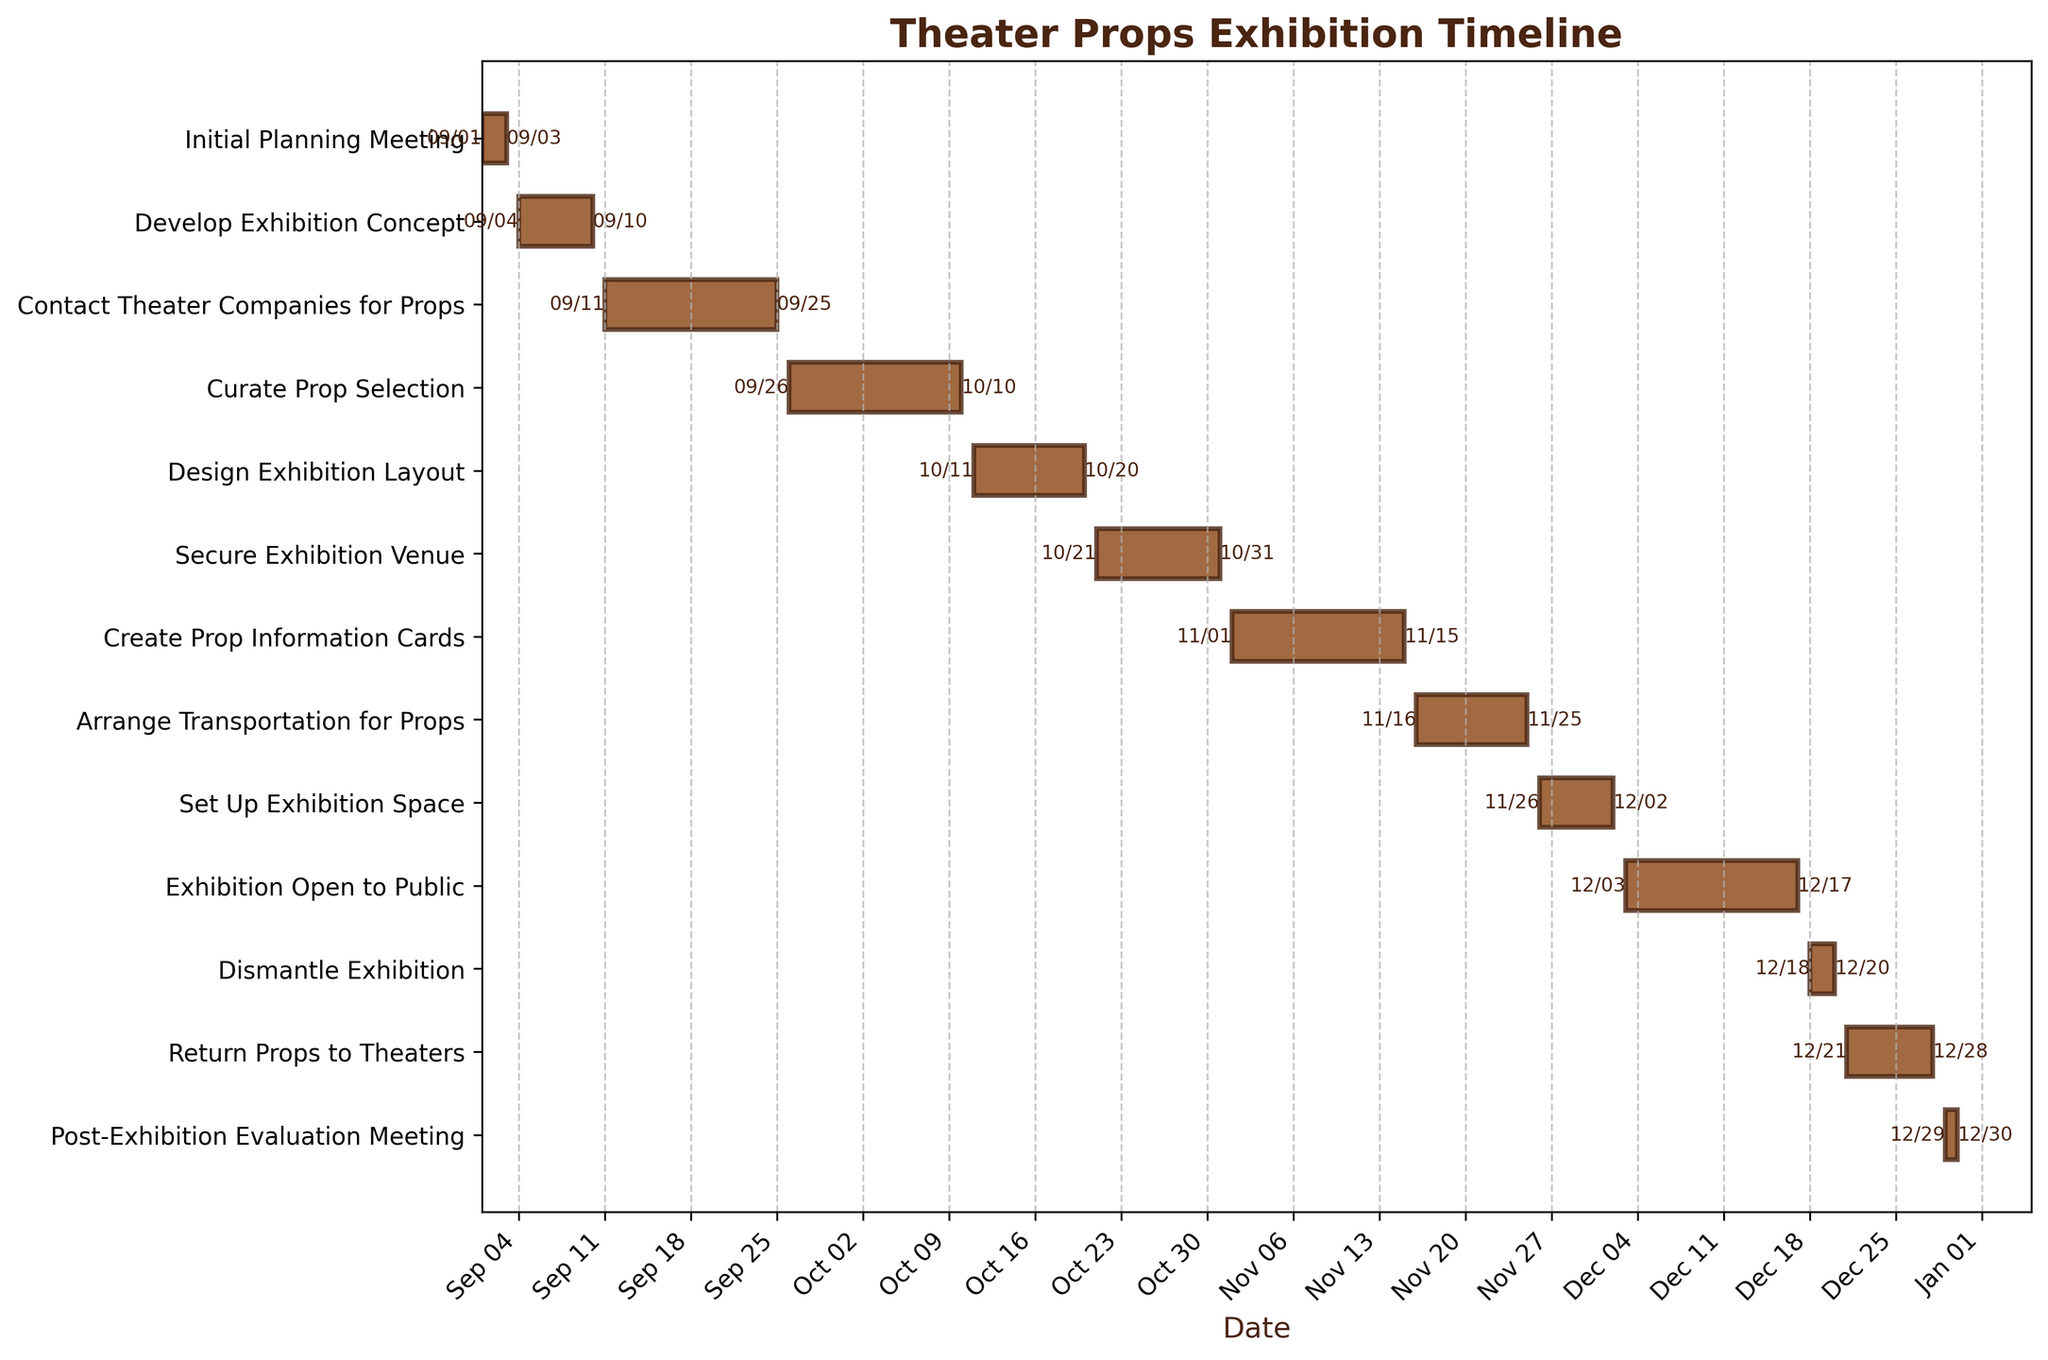What is the title of the Gantt chart? The title is usually displayed at the top of the chart and provides a summary of what the chart is about. Here, the title is "Theater Props Exhibition Timeline," indicating the schedule of tasks leading up to, during, and after the exhibition.
Answer: Theater Props Exhibition Timeline How long is the "Develop Exhibition Concept" task? To find the duration of this task, locate "Develop Exhibition Concept" on the y-axis and examine the length of the corresponding bar on the x-axis. The bar starts at September 4 and ends at September 10, so the duration is the difference between these dates.
Answer: 7 days Which task comes immediately after "Secure Exhibition Venue"? Locate "Secure Exhibition Venue" on the y-axis. The task immediately below it is "Create Prop Information Cards," so this is the next task in the sequence.
Answer: Create Prop Information Cards During which dates does the "Set Up Exhibition Space" task occur? Find "Set Up Exhibition Space" on the y-axis and look at the start and end dates displayed on the corresponding bar. The task occurs from November 26 to December 2.
Answer: November 26 to December 2 How many tasks have a duration of more than two weeks? To answer this, compute the duration of each task from their start and end dates and count the tasks where this duration is greater than 14 days. "Contact Theater Companies for Props" and "Curate Prop Selection" both exceed this duration.
Answer: 2 tasks Which task has the longest duration? Compare the bars for all tasks and identify the one with the longest span between its start and end dates. "Contact Theater Companies for Props" has the longest duration.
Answer: Contact Theater Companies for Props Are there any tasks that start and end within the same month? Check for tasks whose start and end dates fall within the same month by examining the x-axis labels for each task's bar. Multiple tasks do, such as "Initial Planning Meeting," "Develop Exhibition Concept," and "Dismantle Exhibition," among others.
Answer: Yes, multiple tasks What tasks are happening during the first week of December? Look for bars that overlap with the first week of December on the x-axis. Both "Set Up Exhibition Space" and "Exhibition Open to Public" are occurring during this time.
Answer: Set Up Exhibition Space, Exhibition Open to Public Which is the last task in the timeline? Locate the task bar that extends the furthest to the right on the x-axis. "Post-Exhibition Evaluation Meeting" is this task, running from December 29 to December 30.
Answer: Post-Exhibition Evaluation Meeting 